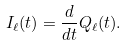Convert formula to latex. <formula><loc_0><loc_0><loc_500><loc_500>I _ { \ell } ( t ) = \frac { d } { d t } Q _ { \ell } ( t ) .</formula> 